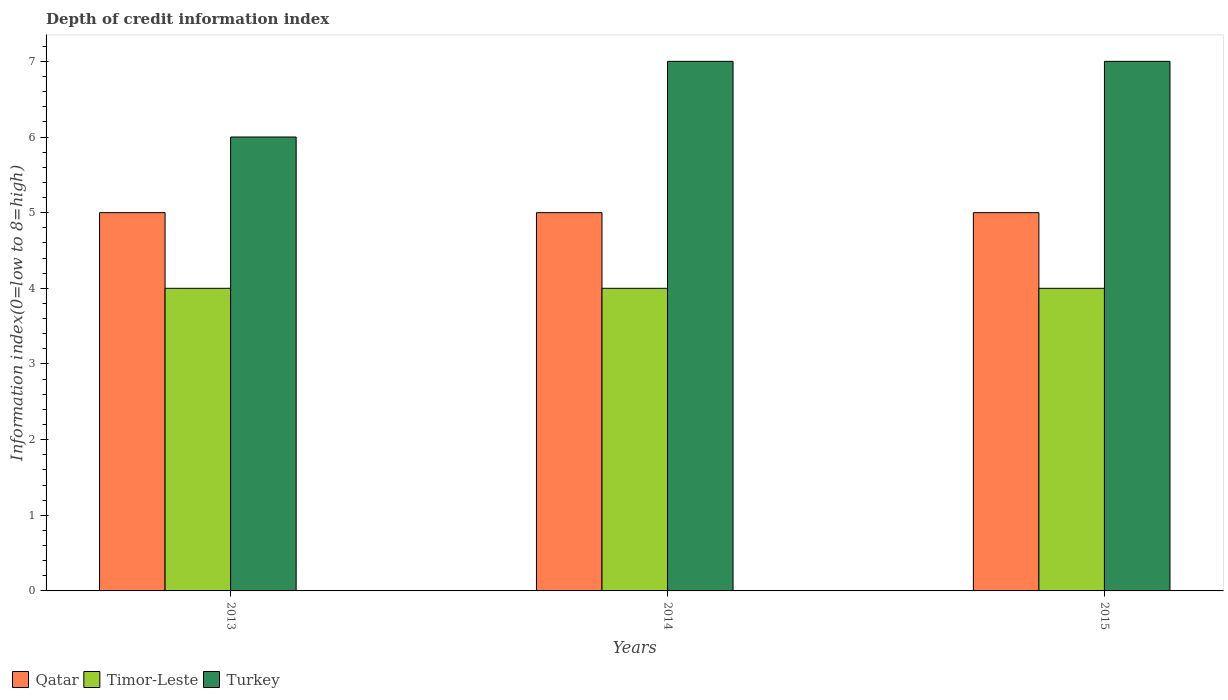How many groups of bars are there?
Make the answer very short. 3. Are the number of bars per tick equal to the number of legend labels?
Provide a succinct answer. Yes. How many bars are there on the 3rd tick from the left?
Provide a succinct answer. 3. What is the label of the 3rd group of bars from the left?
Keep it short and to the point. 2015. In how many cases, is the number of bars for a given year not equal to the number of legend labels?
Ensure brevity in your answer.  0. What is the information index in Timor-Leste in 2015?
Offer a very short reply. 4. Across all years, what is the maximum information index in Qatar?
Ensure brevity in your answer.  5. Across all years, what is the minimum information index in Qatar?
Give a very brief answer. 5. In which year was the information index in Timor-Leste maximum?
Offer a terse response. 2013. What is the total information index in Qatar in the graph?
Offer a very short reply. 15. What is the difference between the information index in Timor-Leste in 2014 and the information index in Qatar in 2013?
Keep it short and to the point. -1. In the year 2013, what is the difference between the information index in Timor-Leste and information index in Turkey?
Make the answer very short. -2. In how many years, is the information index in Qatar greater than 5.8?
Provide a succinct answer. 0. What is the ratio of the information index in Turkey in 2013 to that in 2014?
Your answer should be compact. 0.86. Is the information index in Turkey in 2013 less than that in 2015?
Your response must be concise. Yes. In how many years, is the information index in Turkey greater than the average information index in Turkey taken over all years?
Your response must be concise. 2. Is the sum of the information index in Timor-Leste in 2013 and 2015 greater than the maximum information index in Qatar across all years?
Offer a very short reply. Yes. What does the 2nd bar from the left in 2015 represents?
Provide a succinct answer. Timor-Leste. What does the 3rd bar from the right in 2015 represents?
Your response must be concise. Qatar. Is it the case that in every year, the sum of the information index in Qatar and information index in Timor-Leste is greater than the information index in Turkey?
Give a very brief answer. Yes. Are all the bars in the graph horizontal?
Give a very brief answer. No. How many years are there in the graph?
Provide a short and direct response. 3. What is the difference between two consecutive major ticks on the Y-axis?
Provide a succinct answer. 1. Does the graph contain grids?
Offer a very short reply. No. How are the legend labels stacked?
Provide a short and direct response. Horizontal. What is the title of the graph?
Keep it short and to the point. Depth of credit information index. What is the label or title of the Y-axis?
Your response must be concise. Information index(0=low to 8=high). What is the Information index(0=low to 8=high) in Qatar in 2013?
Offer a terse response. 5. What is the Information index(0=low to 8=high) in Qatar in 2014?
Offer a very short reply. 5. What is the Information index(0=low to 8=high) in Qatar in 2015?
Give a very brief answer. 5. Across all years, what is the maximum Information index(0=low to 8=high) of Qatar?
Ensure brevity in your answer.  5. Across all years, what is the minimum Information index(0=low to 8=high) of Qatar?
Keep it short and to the point. 5. Across all years, what is the minimum Information index(0=low to 8=high) in Timor-Leste?
Your response must be concise. 4. Across all years, what is the minimum Information index(0=low to 8=high) in Turkey?
Provide a short and direct response. 6. What is the total Information index(0=low to 8=high) in Qatar in the graph?
Offer a terse response. 15. What is the total Information index(0=low to 8=high) in Turkey in the graph?
Provide a short and direct response. 20. What is the difference between the Information index(0=low to 8=high) of Timor-Leste in 2013 and that in 2014?
Give a very brief answer. 0. What is the difference between the Information index(0=low to 8=high) in Turkey in 2013 and that in 2014?
Your answer should be compact. -1. What is the difference between the Information index(0=low to 8=high) in Turkey in 2013 and that in 2015?
Provide a short and direct response. -1. What is the difference between the Information index(0=low to 8=high) of Qatar in 2013 and the Information index(0=low to 8=high) of Turkey in 2014?
Give a very brief answer. -2. What is the difference between the Information index(0=low to 8=high) of Timor-Leste in 2013 and the Information index(0=low to 8=high) of Turkey in 2014?
Offer a terse response. -3. What is the difference between the Information index(0=low to 8=high) of Qatar in 2013 and the Information index(0=low to 8=high) of Timor-Leste in 2015?
Provide a short and direct response. 1. What is the difference between the Information index(0=low to 8=high) in Qatar in 2013 and the Information index(0=low to 8=high) in Turkey in 2015?
Make the answer very short. -2. What is the difference between the Information index(0=low to 8=high) in Timor-Leste in 2013 and the Information index(0=low to 8=high) in Turkey in 2015?
Your response must be concise. -3. What is the difference between the Information index(0=low to 8=high) of Qatar in 2014 and the Information index(0=low to 8=high) of Timor-Leste in 2015?
Offer a very short reply. 1. What is the average Information index(0=low to 8=high) of Qatar per year?
Offer a terse response. 5. In the year 2013, what is the difference between the Information index(0=low to 8=high) in Qatar and Information index(0=low to 8=high) in Turkey?
Give a very brief answer. -1. In the year 2013, what is the difference between the Information index(0=low to 8=high) of Timor-Leste and Information index(0=low to 8=high) of Turkey?
Ensure brevity in your answer.  -2. In the year 2014, what is the difference between the Information index(0=low to 8=high) in Qatar and Information index(0=low to 8=high) in Timor-Leste?
Offer a terse response. 1. In the year 2014, what is the difference between the Information index(0=low to 8=high) in Qatar and Information index(0=low to 8=high) in Turkey?
Make the answer very short. -2. In the year 2014, what is the difference between the Information index(0=low to 8=high) of Timor-Leste and Information index(0=low to 8=high) of Turkey?
Your answer should be compact. -3. What is the ratio of the Information index(0=low to 8=high) of Turkey in 2013 to that in 2014?
Offer a terse response. 0.86. What is the ratio of the Information index(0=low to 8=high) in Turkey in 2013 to that in 2015?
Offer a very short reply. 0.86. What is the ratio of the Information index(0=low to 8=high) of Timor-Leste in 2014 to that in 2015?
Your response must be concise. 1. What is the difference between the highest and the second highest Information index(0=low to 8=high) in Timor-Leste?
Give a very brief answer. 0. What is the difference between the highest and the second highest Information index(0=low to 8=high) in Turkey?
Provide a succinct answer. 0. What is the difference between the highest and the lowest Information index(0=low to 8=high) in Qatar?
Offer a terse response. 0. What is the difference between the highest and the lowest Information index(0=low to 8=high) of Turkey?
Keep it short and to the point. 1. 